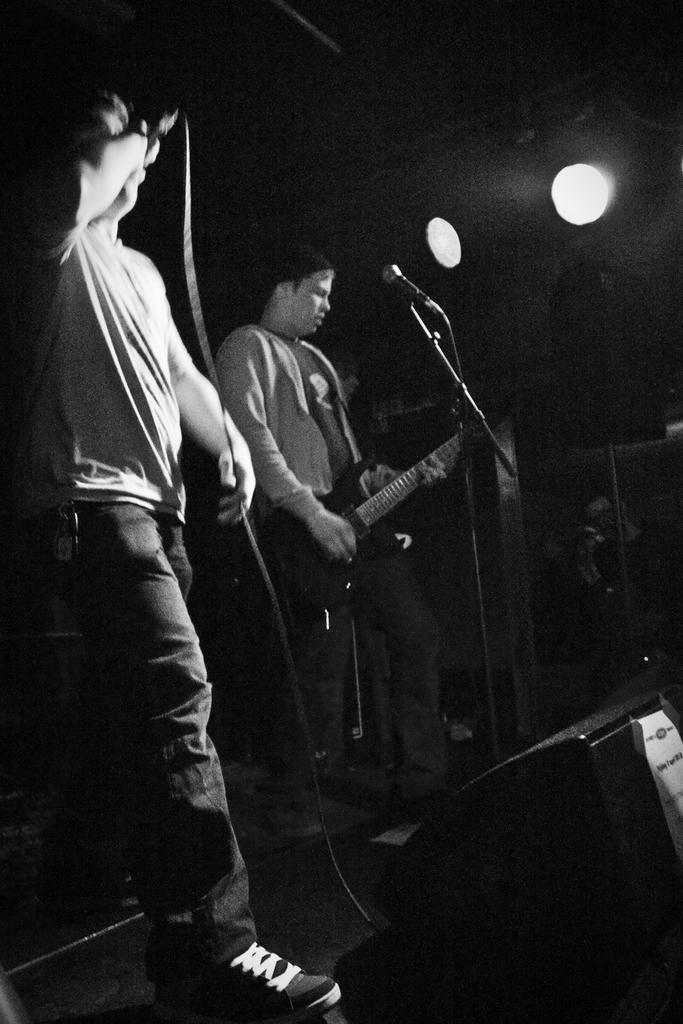What is the person on the right side of the image doing? The person on the right is playing a guitar. What can be seen near the person on the right? The person on the right is in front of a microphone. What is the person on the left side of the image doing? The person on the left is singing. What can be seen near the person on the left? The person on the left is in front of a microphone. What type of nut is being cracked by the person on the left in the image? There is no nut present in the image, and the person on the left is singing, not cracking nuts. What kind of twig is being used by the person on the right to play the guitar in the image? The person on the right is playing a guitar, not a twig, and there is no twig visible in the image. 